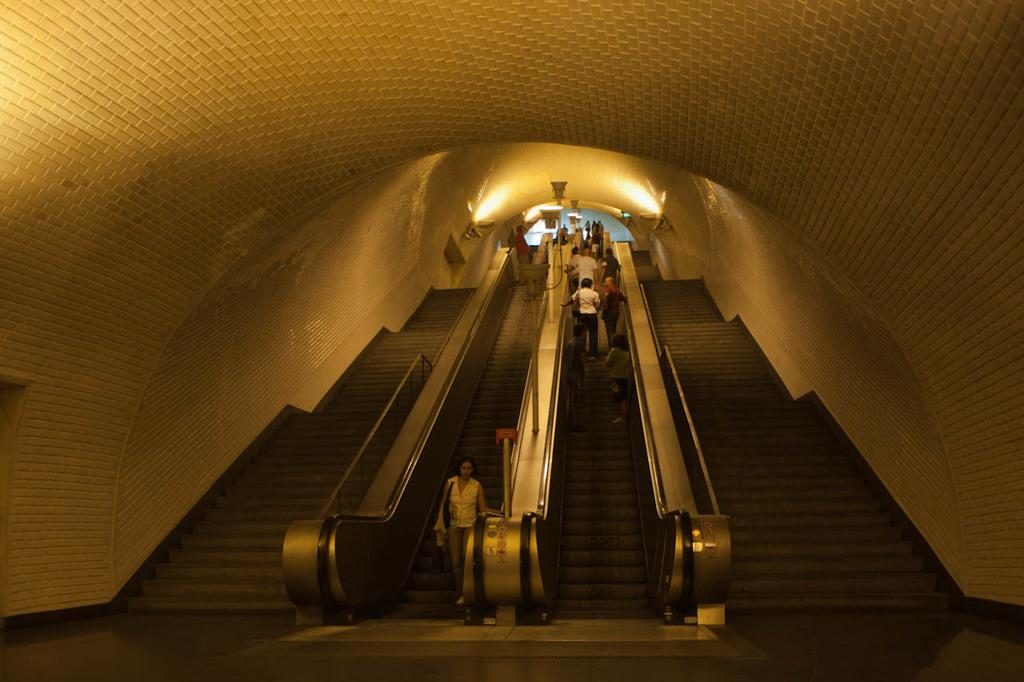Who or what is present in the image? There are people in the image. What are the people doing in the image? The people are standing on an escalator. Can you describe the structure surrounding the escalator? The escalator is under a curved roof. What type of juice can be seen being served by the fairies in the image? There are no fairies or juice present in the image. 